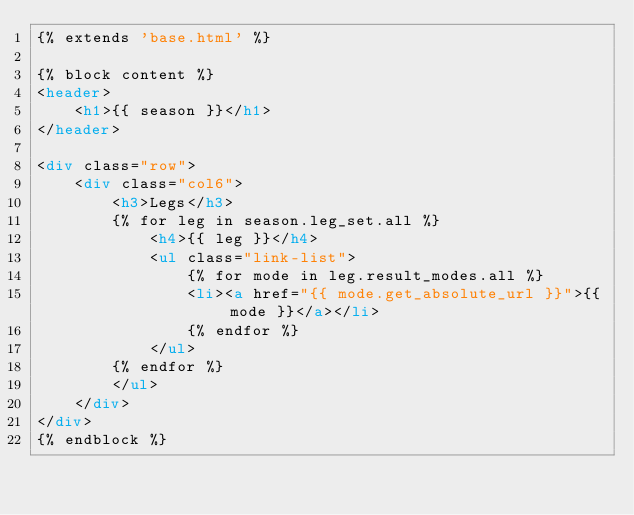<code> <loc_0><loc_0><loc_500><loc_500><_HTML_>{% extends 'base.html' %}

{% block content %}
<header>
    <h1>{{ season }}</h1>
</header>

<div class="row">
    <div class="col6">
        <h3>Legs</h3>
        {% for leg in season.leg_set.all %}
            <h4>{{ leg }}</h4>
            <ul class="link-list">
                {% for mode in leg.result_modes.all %}
                <li><a href="{{ mode.get_absolute_url }}">{{ mode }}</a></li>
                {% endfor %}
            </ul>
        {% endfor %}
        </ul>
    </div>
</div>
{% endblock %}
</code> 